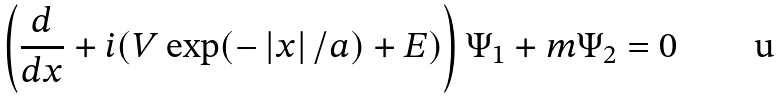Convert formula to latex. <formula><loc_0><loc_0><loc_500><loc_500>\left ( \frac { d } { d x } + i ( V \exp ( - \left | x \right | / a ) + E ) \right ) \Psi _ { 1 } + m \Psi _ { 2 } = 0</formula> 